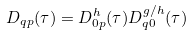<formula> <loc_0><loc_0><loc_500><loc_500>D _ { q p } ( \tau ) = D _ { 0 p } ^ { h } ( \tau ) D _ { q 0 } ^ { g / h } ( \tau )</formula> 